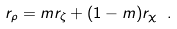<formula> <loc_0><loc_0><loc_500><loc_500>r _ { \rho } = m r _ { \zeta } + ( 1 - m ) r _ { \chi } \ .</formula> 